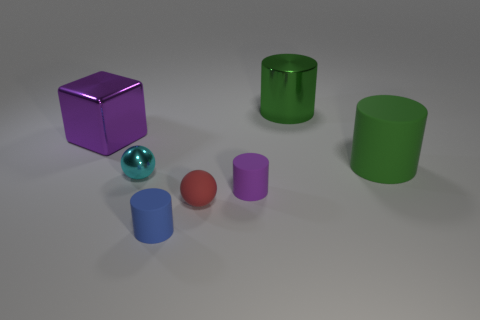How many small things are either metal cylinders or red rubber balls?
Offer a very short reply. 1. Is the material of the large green cylinder that is left of the large matte object the same as the red object?
Your response must be concise. No. There is a rubber object on the left side of the red rubber sphere; what is its color?
Provide a short and direct response. Blue. Is there a block of the same size as the red ball?
Provide a succinct answer. No. There is a red object that is the same size as the purple matte cylinder; what material is it?
Make the answer very short. Rubber. Does the green matte cylinder have the same size as the cyan metal thing in front of the big shiny cylinder?
Your answer should be compact. No. There is a green thing that is right of the large metal cylinder; what material is it?
Make the answer very short. Rubber. Are there an equal number of matte objects that are to the right of the small blue cylinder and tiny red metallic objects?
Your answer should be compact. No. Do the rubber ball and the cyan metallic object have the same size?
Offer a very short reply. Yes. There is a small rubber object that is on the right side of the red thing that is to the left of the tiny purple rubber thing; is there a purple matte thing in front of it?
Keep it short and to the point. No. 